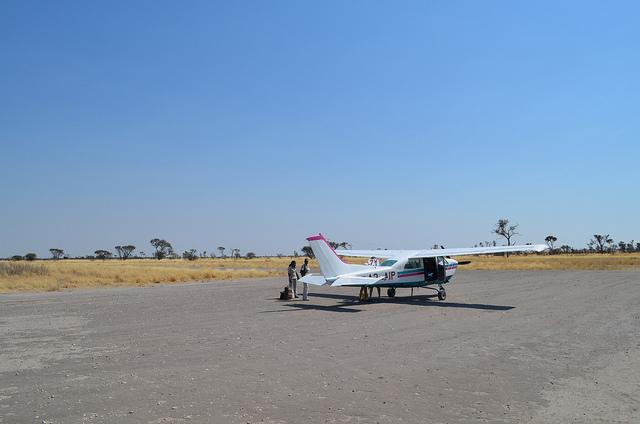What biome is in the background? grassland 